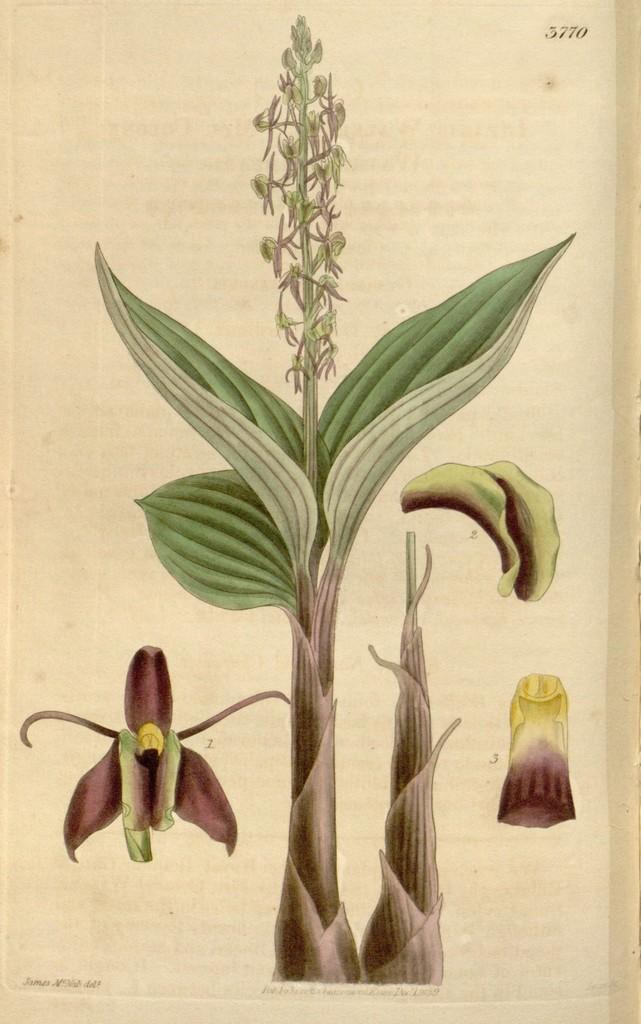Please provide a concise description of this image. This is green color plant. 